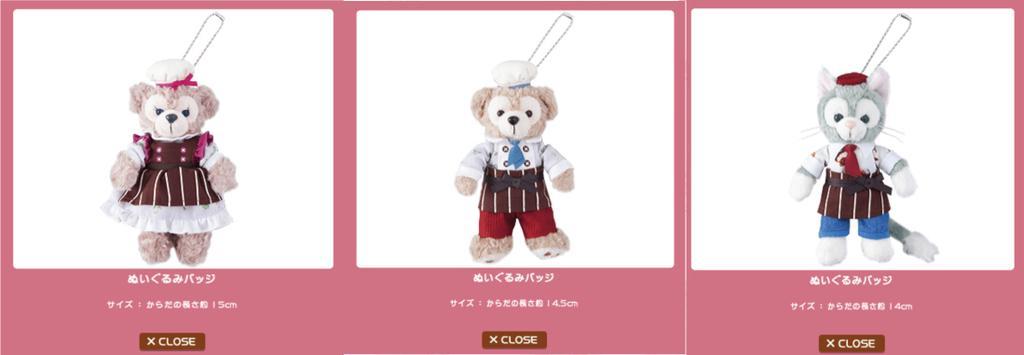Describe this image in one or two sentences. In this image, we can see some pictures of the teddy bears. 